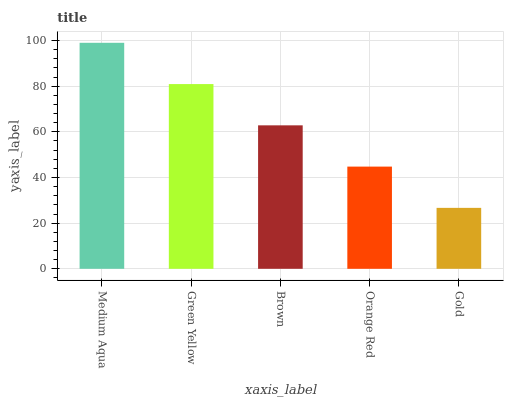Is Gold the minimum?
Answer yes or no. Yes. Is Medium Aqua the maximum?
Answer yes or no. Yes. Is Green Yellow the minimum?
Answer yes or no. No. Is Green Yellow the maximum?
Answer yes or no. No. Is Medium Aqua greater than Green Yellow?
Answer yes or no. Yes. Is Green Yellow less than Medium Aqua?
Answer yes or no. Yes. Is Green Yellow greater than Medium Aqua?
Answer yes or no. No. Is Medium Aqua less than Green Yellow?
Answer yes or no. No. Is Brown the high median?
Answer yes or no. Yes. Is Brown the low median?
Answer yes or no. Yes. Is Medium Aqua the high median?
Answer yes or no. No. Is Orange Red the low median?
Answer yes or no. No. 